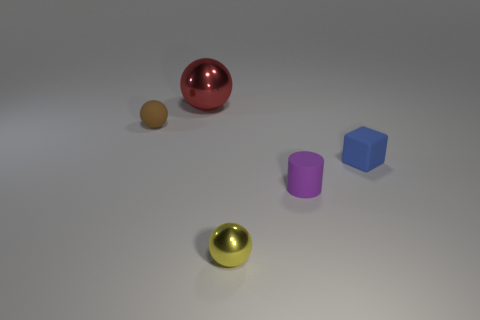Are there any metallic balls that have the same size as the blue matte thing?
Offer a very short reply. Yes. Is the material of the ball that is on the left side of the big shiny ball the same as the blue cube?
Provide a short and direct response. Yes. Are there an equal number of tiny cylinders that are on the left side of the large red metal ball and matte cubes that are to the left of the tiny yellow object?
Keep it short and to the point. Yes. What is the shape of the small object that is left of the purple cylinder and in front of the small blue matte block?
Keep it short and to the point. Sphere. There is a purple matte thing; what number of brown rubber balls are to the right of it?
Provide a short and direct response. 0. How many other things are there of the same shape as the small metal object?
Offer a terse response. 2. Is the number of blue rubber objects less than the number of big green shiny cylinders?
Ensure brevity in your answer.  No. What size is the object that is to the right of the small metallic ball and on the left side of the blue thing?
Ensure brevity in your answer.  Small. There is a metal ball that is behind the metal thing that is in front of the shiny thing that is left of the small yellow object; what is its size?
Ensure brevity in your answer.  Large. The cylinder has what size?
Offer a terse response. Small. 